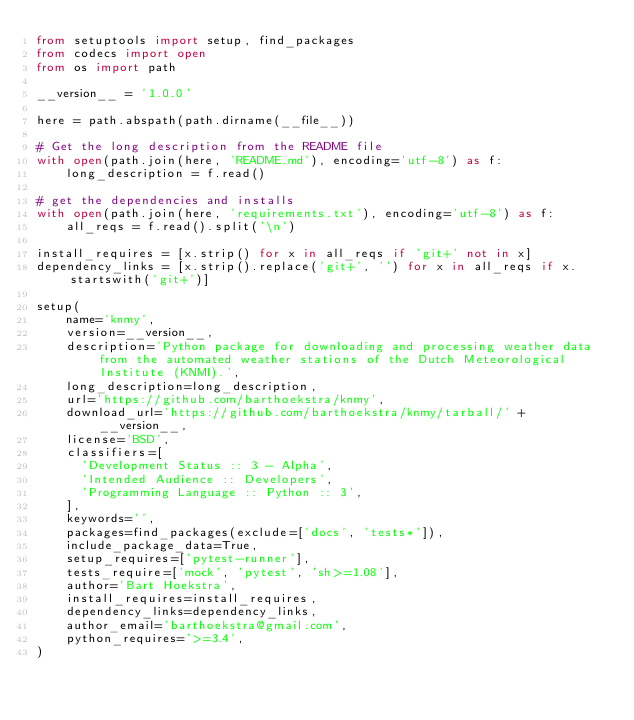Convert code to text. <code><loc_0><loc_0><loc_500><loc_500><_Python_>from setuptools import setup, find_packages
from codecs import open
from os import path

__version__ = '1.0.0'

here = path.abspath(path.dirname(__file__))

# Get the long description from the README file
with open(path.join(here, 'README.md'), encoding='utf-8') as f:
    long_description = f.read()

# get the dependencies and installs
with open(path.join(here, 'requirements.txt'), encoding='utf-8') as f:
    all_reqs = f.read().split('\n')

install_requires = [x.strip() for x in all_reqs if 'git+' not in x]
dependency_links = [x.strip().replace('git+', '') for x in all_reqs if x.startswith('git+')]

setup(
    name='knmy',
    version=__version__,
    description='Python package for downloading and processing weather data from the automated weather stations of the Dutch Meteorological Institute (KNMI).',
    long_description=long_description,
    url='https://github.com/barthoekstra/knmy',
    download_url='https://github.com/barthoekstra/knmy/tarball/' + __version__,
    license='BSD',
    classifiers=[
      'Development Status :: 3 - Alpha',
      'Intended Audience :: Developers',
      'Programming Language :: Python :: 3',
    ],
    keywords='',
    packages=find_packages(exclude=['docs', 'tests*']),
    include_package_data=True,
    setup_requires=['pytest-runner'],
    tests_require=['mock', 'pytest', 'sh>=1.08'],
    author='Bart Hoekstra',
    install_requires=install_requires,
    dependency_links=dependency_links,
    author_email='barthoekstra@gmail.com',
    python_requires='>=3.4',
)
</code> 